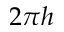Convert formula to latex. <formula><loc_0><loc_0><loc_500><loc_500>2 \pi h</formula> 